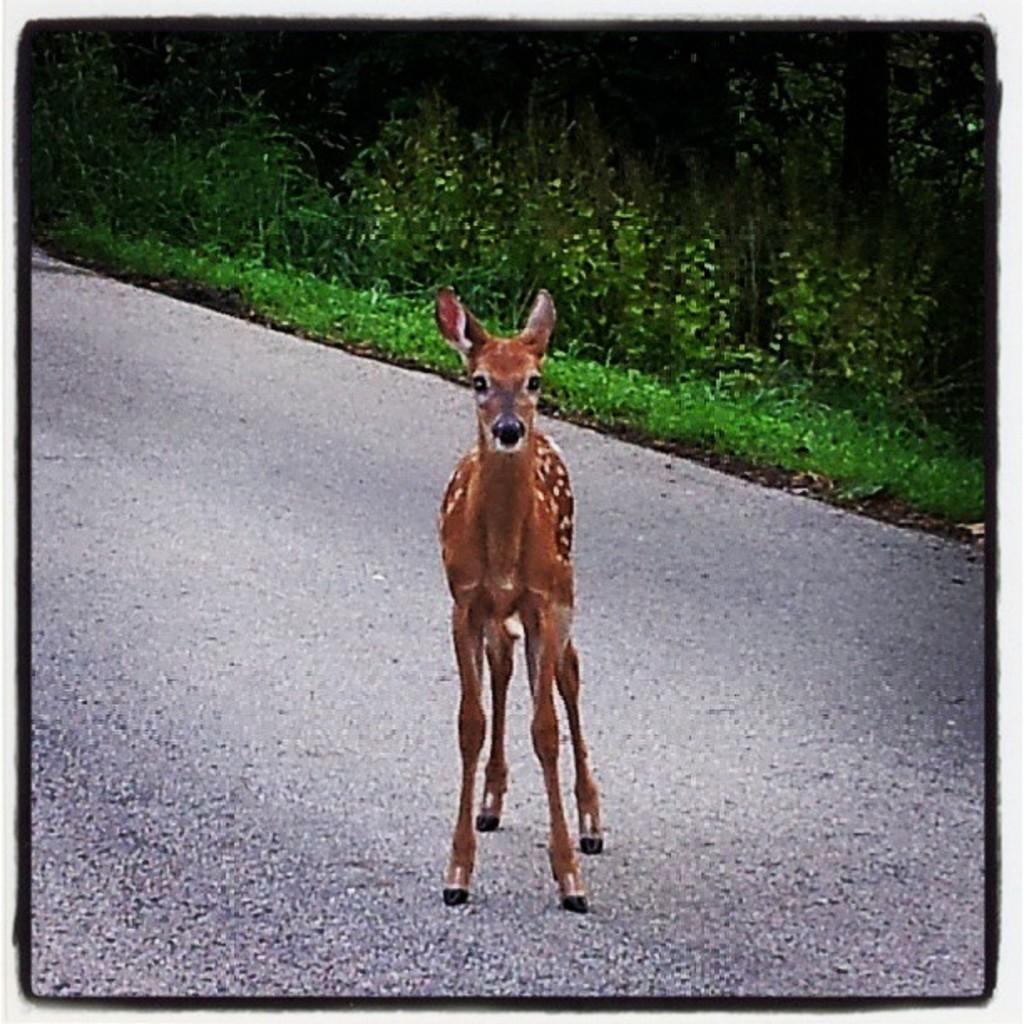What is the main subject of the image? There is a photo in the image. What can be seen in the photo? The photo contains an animal on the road. What type of natural environment is visible in the background of the photo? There is grass, plants, and trees visible in the background of the photo. Where is the stove located in the image? There is no stove present in the image. What type of society is depicted in the image? The image does not depict a society; it features a photo of an animal on the road with a natural background. 